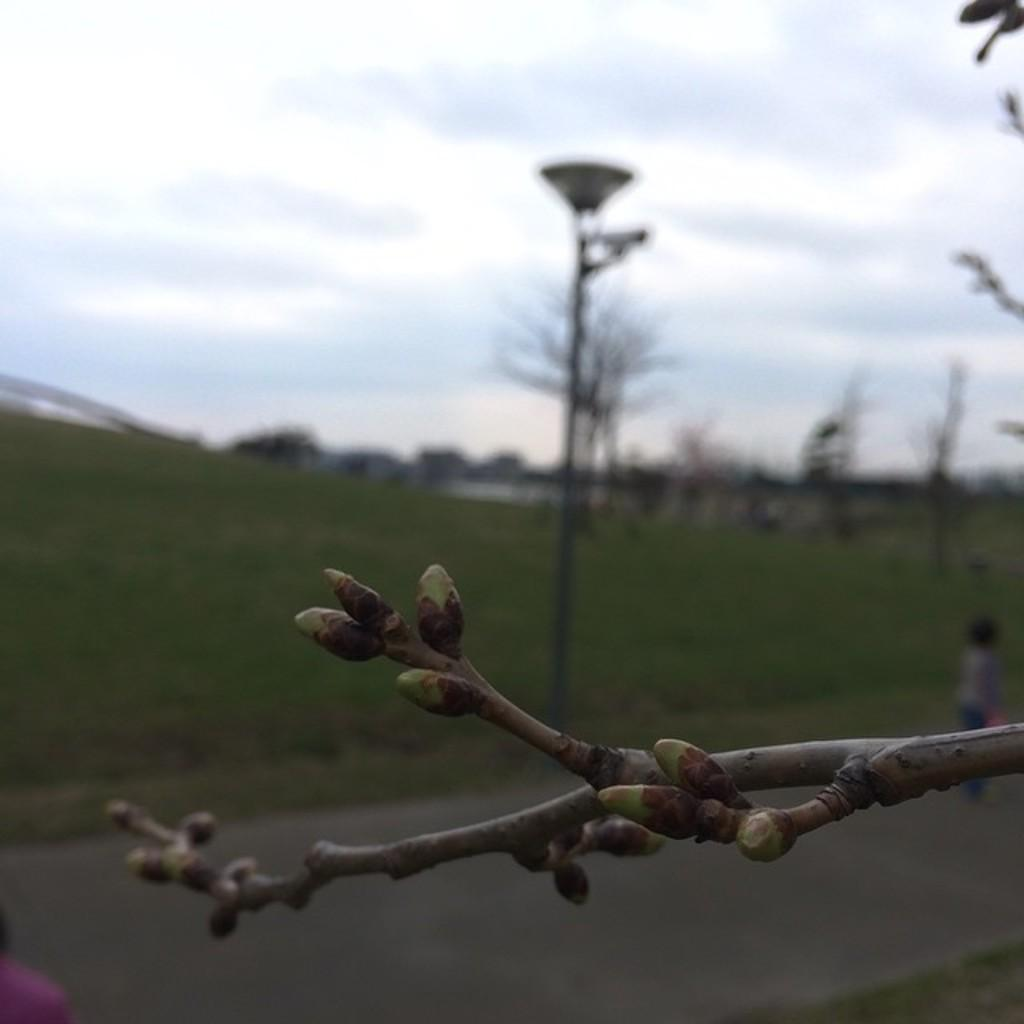What is the main subject of the image? There is a plant stem in the image. What can be seen in the background of the image? There are trees and poles in the background of the image. What is at the bottom of the image? There is a road at the bottom of the image. What is visible in the sky at the top of the image? There are clouds in the sky at the top of the image. What type of coal is being used in the oven in the image? There is no oven or coal present in the image. How many clouds are visible in the image? The number of clouds visible in the image cannot be determined from the provided facts. 